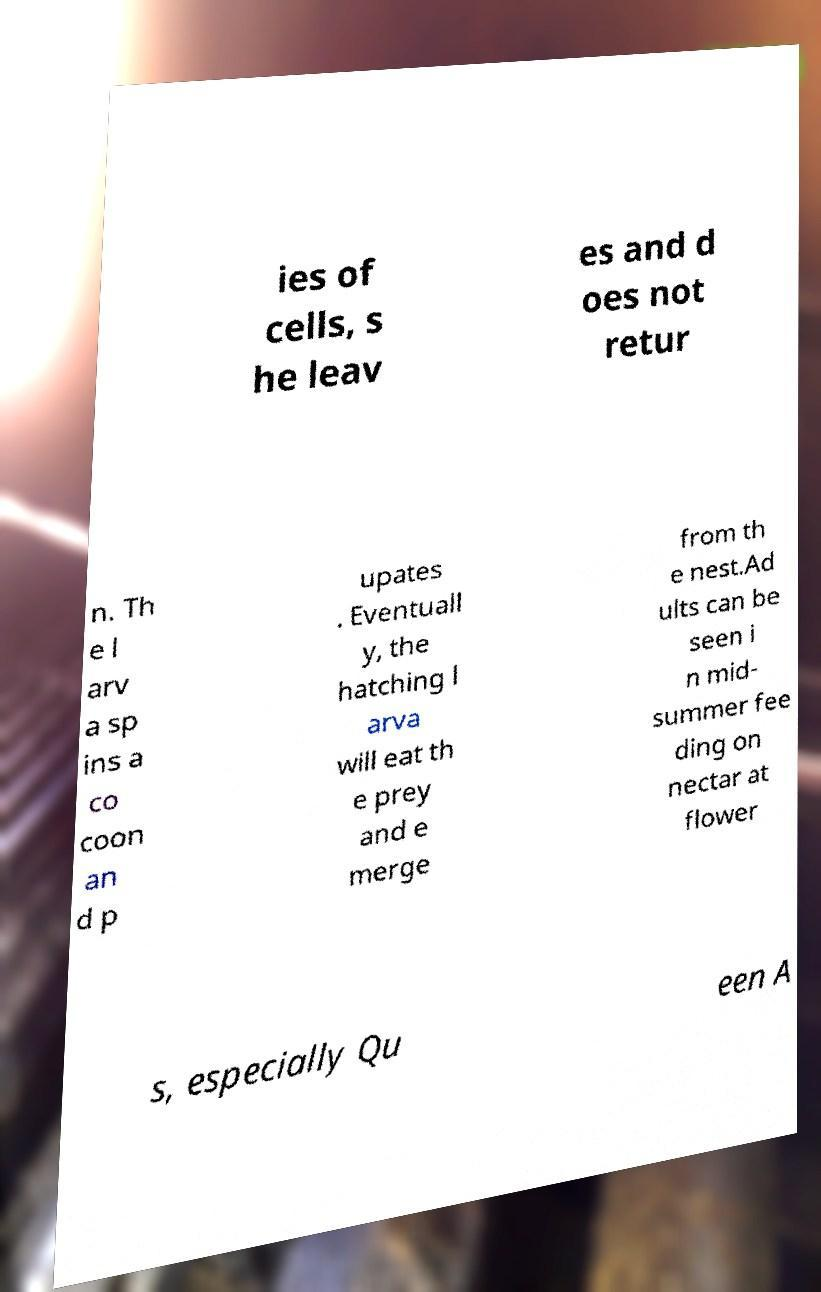There's text embedded in this image that I need extracted. Can you transcribe it verbatim? ies of cells, s he leav es and d oes not retur n. Th e l arv a sp ins a co coon an d p upates . Eventuall y, the hatching l arva will eat th e prey and e merge from th e nest.Ad ults can be seen i n mid- summer fee ding on nectar at flower s, especially Qu een A 